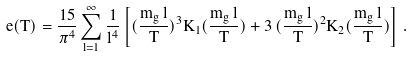<formula> <loc_0><loc_0><loc_500><loc_500>e ( T ) = \frac { 1 5 } { \pi ^ { 4 } } \sum _ { l = 1 } ^ { \infty } \frac { 1 } { l ^ { 4 } } \left [ ( \frac { m _ { g } \, l } { T } ) ^ { 3 } K _ { 1 } ( \frac { m _ { g } \, l } { T } ) + 3 \, ( \frac { m _ { g } \, l } { T } ) ^ { 2 } K _ { 2 } ( \frac { m _ { g } \, l } { T } ) \right ] \, .</formula> 